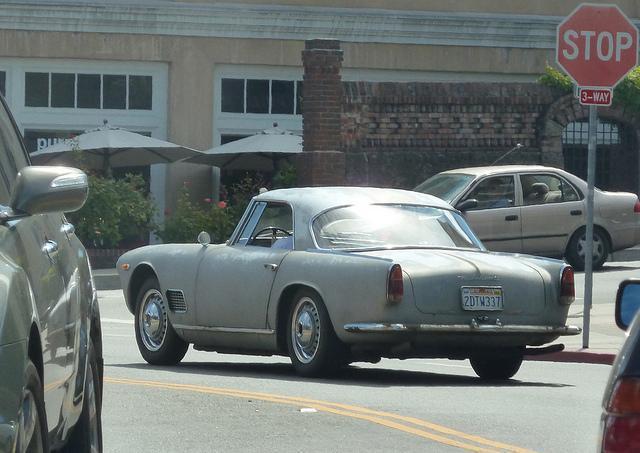How many turn options do cars entering this intersection have?
Indicate the correct response and explain using: 'Answer: answer
Rationale: rationale.'
Options: One, two, five, none. Answer: two.
Rationale: Cars can turn left or right. 